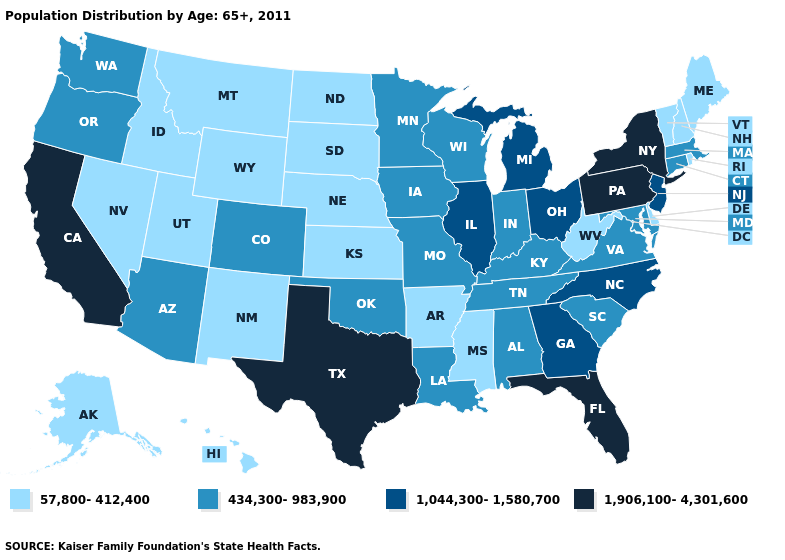Name the states that have a value in the range 1,906,100-4,301,600?
Quick response, please. California, Florida, New York, Pennsylvania, Texas. Which states hav the highest value in the MidWest?
Write a very short answer. Illinois, Michigan, Ohio. Name the states that have a value in the range 1,044,300-1,580,700?
Answer briefly. Georgia, Illinois, Michigan, New Jersey, North Carolina, Ohio. Does the map have missing data?
Be succinct. No. Does the first symbol in the legend represent the smallest category?
Keep it brief. Yes. Which states have the lowest value in the South?
Keep it brief. Arkansas, Delaware, Mississippi, West Virginia. Among the states that border Massachusetts , does New York have the highest value?
Answer briefly. Yes. Does Michigan have the lowest value in the USA?
Write a very short answer. No. Among the states that border Maine , which have the highest value?
Write a very short answer. New Hampshire. Which states have the highest value in the USA?
Answer briefly. California, Florida, New York, Pennsylvania, Texas. How many symbols are there in the legend?
Write a very short answer. 4. Is the legend a continuous bar?
Write a very short answer. No. Which states have the highest value in the USA?
Quick response, please. California, Florida, New York, Pennsylvania, Texas. Which states have the lowest value in the Northeast?
Give a very brief answer. Maine, New Hampshire, Rhode Island, Vermont. 